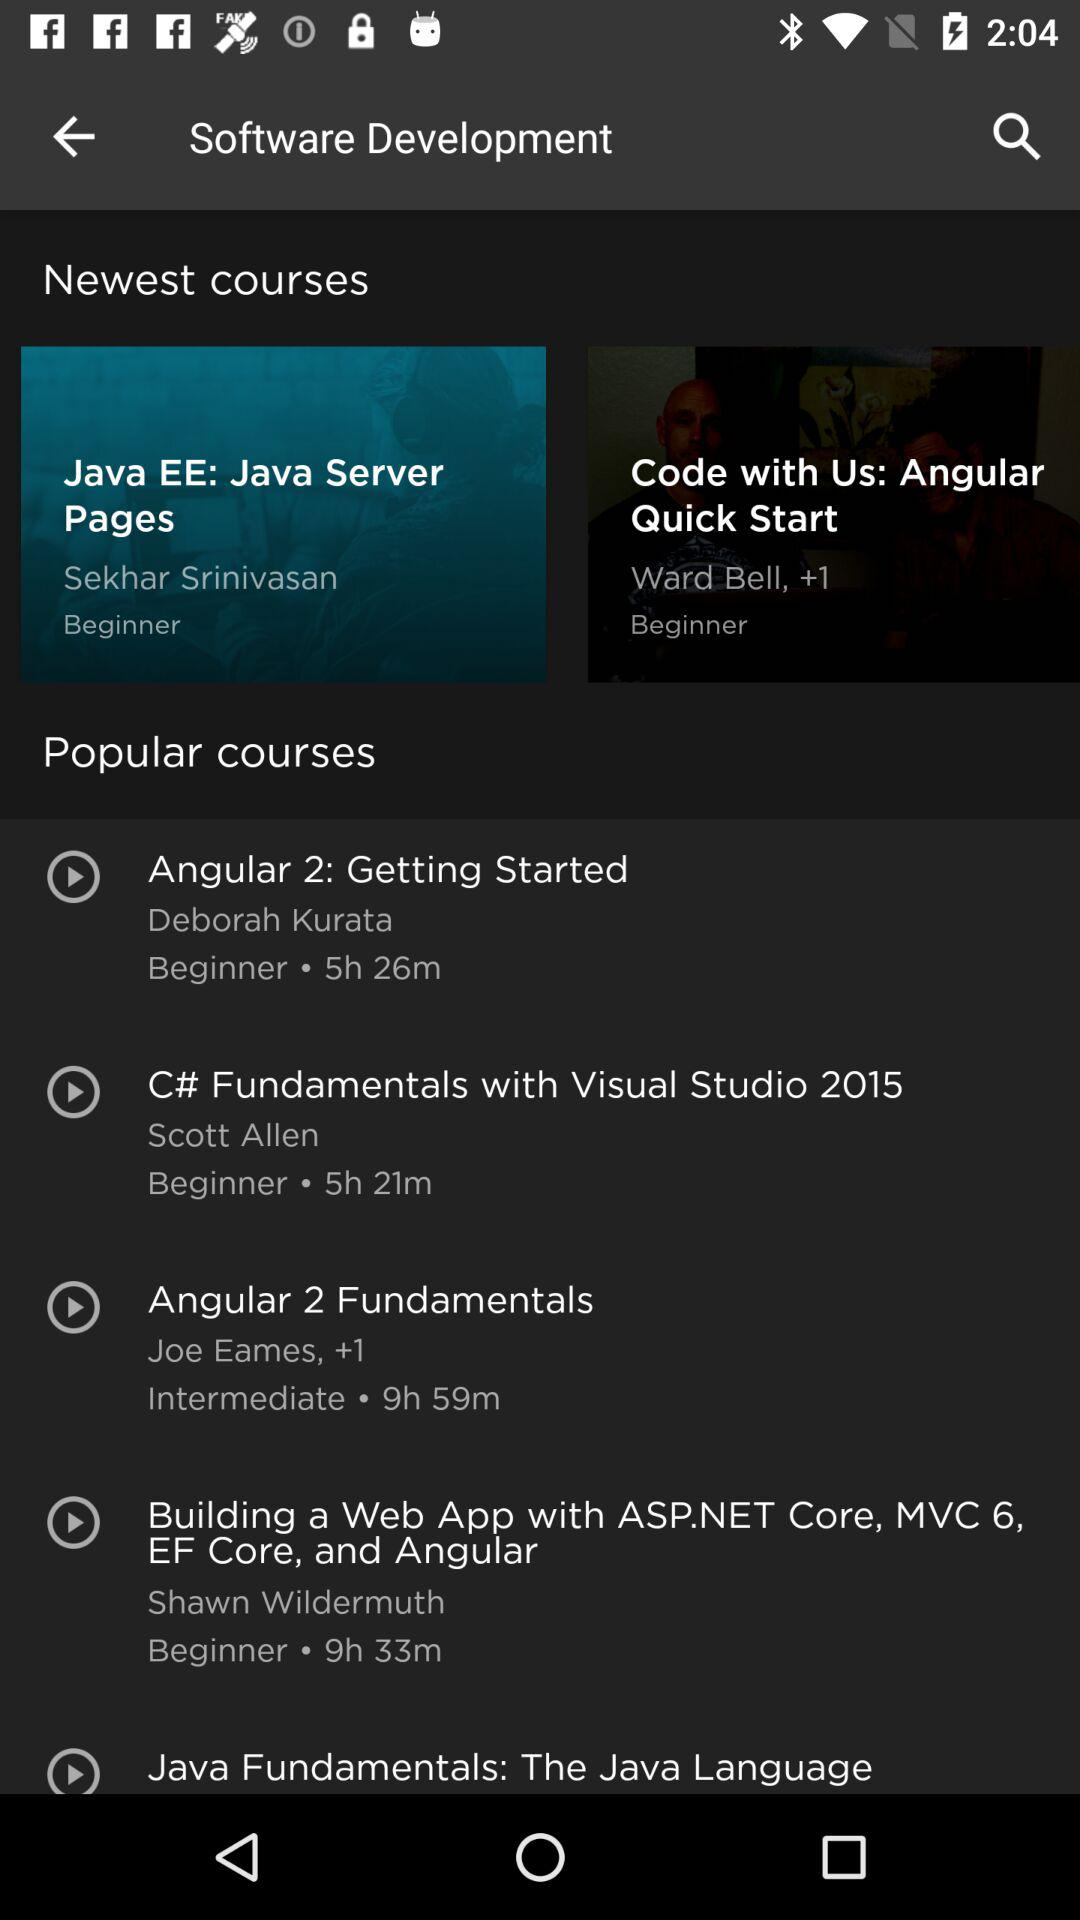Which "Newest courses" are selected? The selected course is "Java EE: Java Server Pages". 